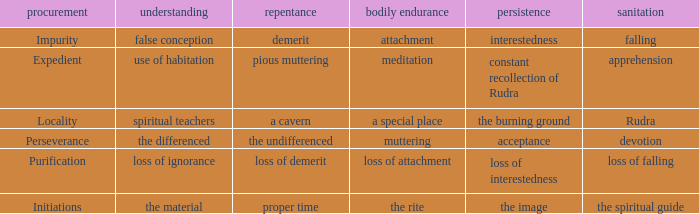 what's the permanence of the body where constancy is interestedness Attachment. 